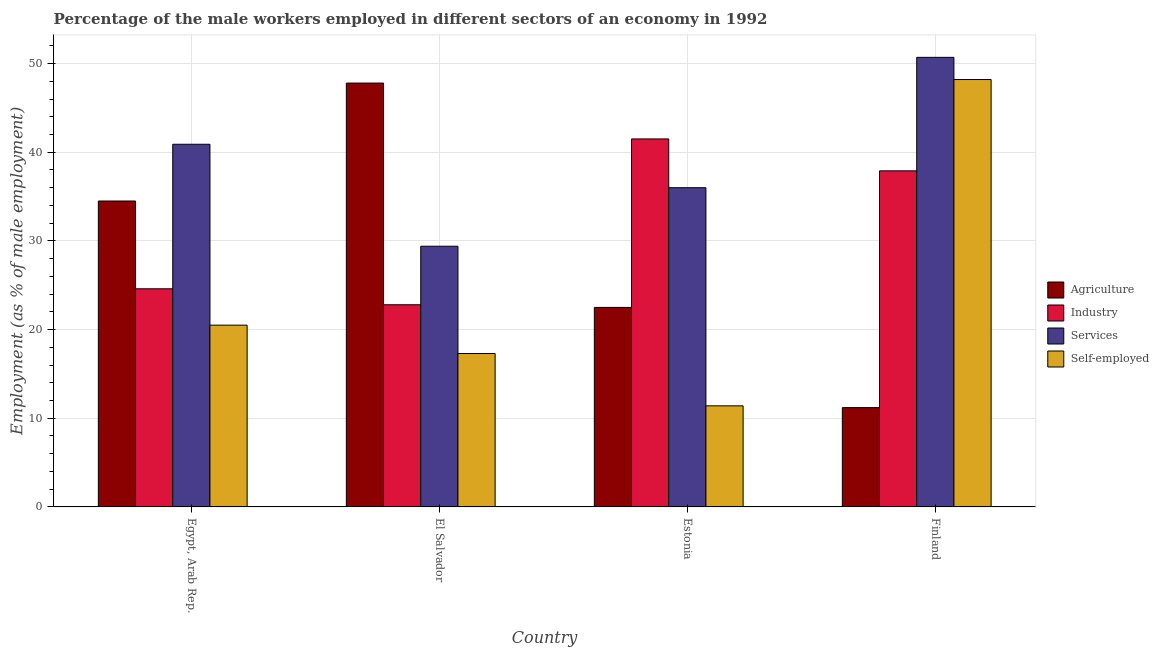How many different coloured bars are there?
Give a very brief answer. 4. How many groups of bars are there?
Your answer should be very brief. 4. How many bars are there on the 3rd tick from the left?
Give a very brief answer. 4. What is the label of the 1st group of bars from the left?
Your answer should be compact. Egypt, Arab Rep. In how many cases, is the number of bars for a given country not equal to the number of legend labels?
Make the answer very short. 0. What is the percentage of male workers in agriculture in Finland?
Offer a very short reply. 11.2. Across all countries, what is the maximum percentage of male workers in industry?
Ensure brevity in your answer.  41.5. Across all countries, what is the minimum percentage of male workers in services?
Your answer should be compact. 29.4. In which country was the percentage of male workers in agriculture maximum?
Your answer should be compact. El Salvador. In which country was the percentage of male workers in industry minimum?
Give a very brief answer. El Salvador. What is the total percentage of male workers in services in the graph?
Offer a terse response. 157. What is the difference between the percentage of male workers in industry in El Salvador and that in Estonia?
Offer a very short reply. -18.7. What is the difference between the percentage of male workers in agriculture in El Salvador and the percentage of self employed male workers in Egypt, Arab Rep.?
Give a very brief answer. 27.3. What is the average percentage of self employed male workers per country?
Keep it short and to the point. 24.35. What is the difference between the percentage of male workers in services and percentage of male workers in industry in Finland?
Offer a very short reply. 12.8. In how many countries, is the percentage of self employed male workers greater than 22 %?
Your answer should be very brief. 1. What is the ratio of the percentage of male workers in agriculture in Estonia to that in Finland?
Make the answer very short. 2.01. What is the difference between the highest and the second highest percentage of male workers in services?
Your response must be concise. 9.8. What is the difference between the highest and the lowest percentage of male workers in industry?
Your answer should be compact. 18.7. In how many countries, is the percentage of male workers in industry greater than the average percentage of male workers in industry taken over all countries?
Your response must be concise. 2. Is it the case that in every country, the sum of the percentage of male workers in industry and percentage of male workers in agriculture is greater than the sum of percentage of self employed male workers and percentage of male workers in services?
Offer a terse response. No. What does the 4th bar from the left in El Salvador represents?
Make the answer very short. Self-employed. What does the 1st bar from the right in Estonia represents?
Offer a terse response. Self-employed. Is it the case that in every country, the sum of the percentage of male workers in agriculture and percentage of male workers in industry is greater than the percentage of male workers in services?
Give a very brief answer. No. How many countries are there in the graph?
Your answer should be very brief. 4. What is the difference between two consecutive major ticks on the Y-axis?
Provide a succinct answer. 10. Are the values on the major ticks of Y-axis written in scientific E-notation?
Give a very brief answer. No. How are the legend labels stacked?
Your answer should be compact. Vertical. What is the title of the graph?
Provide a succinct answer. Percentage of the male workers employed in different sectors of an economy in 1992. What is the label or title of the Y-axis?
Offer a terse response. Employment (as % of male employment). What is the Employment (as % of male employment) of Agriculture in Egypt, Arab Rep.?
Provide a short and direct response. 34.5. What is the Employment (as % of male employment) of Industry in Egypt, Arab Rep.?
Your answer should be compact. 24.6. What is the Employment (as % of male employment) in Services in Egypt, Arab Rep.?
Offer a terse response. 40.9. What is the Employment (as % of male employment) of Self-employed in Egypt, Arab Rep.?
Your response must be concise. 20.5. What is the Employment (as % of male employment) of Agriculture in El Salvador?
Keep it short and to the point. 47.8. What is the Employment (as % of male employment) in Industry in El Salvador?
Provide a succinct answer. 22.8. What is the Employment (as % of male employment) in Services in El Salvador?
Keep it short and to the point. 29.4. What is the Employment (as % of male employment) of Self-employed in El Salvador?
Provide a short and direct response. 17.3. What is the Employment (as % of male employment) of Agriculture in Estonia?
Your answer should be very brief. 22.5. What is the Employment (as % of male employment) of Industry in Estonia?
Your response must be concise. 41.5. What is the Employment (as % of male employment) of Self-employed in Estonia?
Your answer should be very brief. 11.4. What is the Employment (as % of male employment) of Agriculture in Finland?
Give a very brief answer. 11.2. What is the Employment (as % of male employment) of Industry in Finland?
Your answer should be very brief. 37.9. What is the Employment (as % of male employment) of Services in Finland?
Your answer should be compact. 50.7. What is the Employment (as % of male employment) in Self-employed in Finland?
Provide a short and direct response. 48.2. Across all countries, what is the maximum Employment (as % of male employment) of Agriculture?
Give a very brief answer. 47.8. Across all countries, what is the maximum Employment (as % of male employment) of Industry?
Provide a short and direct response. 41.5. Across all countries, what is the maximum Employment (as % of male employment) in Services?
Keep it short and to the point. 50.7. Across all countries, what is the maximum Employment (as % of male employment) of Self-employed?
Offer a very short reply. 48.2. Across all countries, what is the minimum Employment (as % of male employment) of Agriculture?
Provide a short and direct response. 11.2. Across all countries, what is the minimum Employment (as % of male employment) in Industry?
Your answer should be compact. 22.8. Across all countries, what is the minimum Employment (as % of male employment) in Services?
Make the answer very short. 29.4. Across all countries, what is the minimum Employment (as % of male employment) of Self-employed?
Offer a terse response. 11.4. What is the total Employment (as % of male employment) in Agriculture in the graph?
Offer a terse response. 116. What is the total Employment (as % of male employment) in Industry in the graph?
Your answer should be very brief. 126.8. What is the total Employment (as % of male employment) of Services in the graph?
Your answer should be very brief. 157. What is the total Employment (as % of male employment) of Self-employed in the graph?
Provide a short and direct response. 97.4. What is the difference between the Employment (as % of male employment) in Industry in Egypt, Arab Rep. and that in El Salvador?
Your response must be concise. 1.8. What is the difference between the Employment (as % of male employment) in Services in Egypt, Arab Rep. and that in El Salvador?
Make the answer very short. 11.5. What is the difference between the Employment (as % of male employment) of Self-employed in Egypt, Arab Rep. and that in El Salvador?
Give a very brief answer. 3.2. What is the difference between the Employment (as % of male employment) of Agriculture in Egypt, Arab Rep. and that in Estonia?
Your answer should be compact. 12. What is the difference between the Employment (as % of male employment) of Industry in Egypt, Arab Rep. and that in Estonia?
Provide a succinct answer. -16.9. What is the difference between the Employment (as % of male employment) of Agriculture in Egypt, Arab Rep. and that in Finland?
Offer a terse response. 23.3. What is the difference between the Employment (as % of male employment) in Industry in Egypt, Arab Rep. and that in Finland?
Ensure brevity in your answer.  -13.3. What is the difference between the Employment (as % of male employment) of Services in Egypt, Arab Rep. and that in Finland?
Ensure brevity in your answer.  -9.8. What is the difference between the Employment (as % of male employment) of Self-employed in Egypt, Arab Rep. and that in Finland?
Provide a succinct answer. -27.7. What is the difference between the Employment (as % of male employment) of Agriculture in El Salvador and that in Estonia?
Give a very brief answer. 25.3. What is the difference between the Employment (as % of male employment) of Industry in El Salvador and that in Estonia?
Give a very brief answer. -18.7. What is the difference between the Employment (as % of male employment) of Services in El Salvador and that in Estonia?
Provide a short and direct response. -6.6. What is the difference between the Employment (as % of male employment) in Agriculture in El Salvador and that in Finland?
Keep it short and to the point. 36.6. What is the difference between the Employment (as % of male employment) of Industry in El Salvador and that in Finland?
Keep it short and to the point. -15.1. What is the difference between the Employment (as % of male employment) of Services in El Salvador and that in Finland?
Make the answer very short. -21.3. What is the difference between the Employment (as % of male employment) of Self-employed in El Salvador and that in Finland?
Provide a succinct answer. -30.9. What is the difference between the Employment (as % of male employment) of Services in Estonia and that in Finland?
Provide a succinct answer. -14.7. What is the difference between the Employment (as % of male employment) in Self-employed in Estonia and that in Finland?
Offer a terse response. -36.8. What is the difference between the Employment (as % of male employment) in Agriculture in Egypt, Arab Rep. and the Employment (as % of male employment) in Self-employed in El Salvador?
Your response must be concise. 17.2. What is the difference between the Employment (as % of male employment) in Industry in Egypt, Arab Rep. and the Employment (as % of male employment) in Services in El Salvador?
Ensure brevity in your answer.  -4.8. What is the difference between the Employment (as % of male employment) of Services in Egypt, Arab Rep. and the Employment (as % of male employment) of Self-employed in El Salvador?
Make the answer very short. 23.6. What is the difference between the Employment (as % of male employment) in Agriculture in Egypt, Arab Rep. and the Employment (as % of male employment) in Industry in Estonia?
Make the answer very short. -7. What is the difference between the Employment (as % of male employment) in Agriculture in Egypt, Arab Rep. and the Employment (as % of male employment) in Self-employed in Estonia?
Make the answer very short. 23.1. What is the difference between the Employment (as % of male employment) of Industry in Egypt, Arab Rep. and the Employment (as % of male employment) of Services in Estonia?
Keep it short and to the point. -11.4. What is the difference between the Employment (as % of male employment) of Services in Egypt, Arab Rep. and the Employment (as % of male employment) of Self-employed in Estonia?
Your answer should be very brief. 29.5. What is the difference between the Employment (as % of male employment) of Agriculture in Egypt, Arab Rep. and the Employment (as % of male employment) of Services in Finland?
Offer a very short reply. -16.2. What is the difference between the Employment (as % of male employment) in Agriculture in Egypt, Arab Rep. and the Employment (as % of male employment) in Self-employed in Finland?
Provide a succinct answer. -13.7. What is the difference between the Employment (as % of male employment) of Industry in Egypt, Arab Rep. and the Employment (as % of male employment) of Services in Finland?
Provide a short and direct response. -26.1. What is the difference between the Employment (as % of male employment) of Industry in Egypt, Arab Rep. and the Employment (as % of male employment) of Self-employed in Finland?
Give a very brief answer. -23.6. What is the difference between the Employment (as % of male employment) in Agriculture in El Salvador and the Employment (as % of male employment) in Industry in Estonia?
Provide a succinct answer. 6.3. What is the difference between the Employment (as % of male employment) of Agriculture in El Salvador and the Employment (as % of male employment) of Services in Estonia?
Your response must be concise. 11.8. What is the difference between the Employment (as % of male employment) of Agriculture in El Salvador and the Employment (as % of male employment) of Self-employed in Estonia?
Ensure brevity in your answer.  36.4. What is the difference between the Employment (as % of male employment) in Industry in El Salvador and the Employment (as % of male employment) in Services in Estonia?
Ensure brevity in your answer.  -13.2. What is the difference between the Employment (as % of male employment) of Industry in El Salvador and the Employment (as % of male employment) of Services in Finland?
Ensure brevity in your answer.  -27.9. What is the difference between the Employment (as % of male employment) in Industry in El Salvador and the Employment (as % of male employment) in Self-employed in Finland?
Provide a succinct answer. -25.4. What is the difference between the Employment (as % of male employment) in Services in El Salvador and the Employment (as % of male employment) in Self-employed in Finland?
Offer a terse response. -18.8. What is the difference between the Employment (as % of male employment) in Agriculture in Estonia and the Employment (as % of male employment) in Industry in Finland?
Give a very brief answer. -15.4. What is the difference between the Employment (as % of male employment) in Agriculture in Estonia and the Employment (as % of male employment) in Services in Finland?
Ensure brevity in your answer.  -28.2. What is the difference between the Employment (as % of male employment) of Agriculture in Estonia and the Employment (as % of male employment) of Self-employed in Finland?
Provide a succinct answer. -25.7. What is the difference between the Employment (as % of male employment) of Industry in Estonia and the Employment (as % of male employment) of Services in Finland?
Provide a short and direct response. -9.2. What is the difference between the Employment (as % of male employment) of Industry in Estonia and the Employment (as % of male employment) of Self-employed in Finland?
Your answer should be very brief. -6.7. What is the average Employment (as % of male employment) of Industry per country?
Your answer should be compact. 31.7. What is the average Employment (as % of male employment) of Services per country?
Provide a succinct answer. 39.25. What is the average Employment (as % of male employment) in Self-employed per country?
Provide a succinct answer. 24.35. What is the difference between the Employment (as % of male employment) of Agriculture and Employment (as % of male employment) of Industry in Egypt, Arab Rep.?
Offer a very short reply. 9.9. What is the difference between the Employment (as % of male employment) of Agriculture and Employment (as % of male employment) of Self-employed in Egypt, Arab Rep.?
Offer a very short reply. 14. What is the difference between the Employment (as % of male employment) of Industry and Employment (as % of male employment) of Services in Egypt, Arab Rep.?
Ensure brevity in your answer.  -16.3. What is the difference between the Employment (as % of male employment) in Industry and Employment (as % of male employment) in Self-employed in Egypt, Arab Rep.?
Offer a terse response. 4.1. What is the difference between the Employment (as % of male employment) of Services and Employment (as % of male employment) of Self-employed in Egypt, Arab Rep.?
Provide a short and direct response. 20.4. What is the difference between the Employment (as % of male employment) in Agriculture and Employment (as % of male employment) in Industry in El Salvador?
Offer a terse response. 25. What is the difference between the Employment (as % of male employment) in Agriculture and Employment (as % of male employment) in Self-employed in El Salvador?
Give a very brief answer. 30.5. What is the difference between the Employment (as % of male employment) in Industry and Employment (as % of male employment) in Self-employed in El Salvador?
Provide a short and direct response. 5.5. What is the difference between the Employment (as % of male employment) in Services and Employment (as % of male employment) in Self-employed in El Salvador?
Give a very brief answer. 12.1. What is the difference between the Employment (as % of male employment) in Agriculture and Employment (as % of male employment) in Industry in Estonia?
Give a very brief answer. -19. What is the difference between the Employment (as % of male employment) of Agriculture and Employment (as % of male employment) of Services in Estonia?
Your answer should be very brief. -13.5. What is the difference between the Employment (as % of male employment) of Industry and Employment (as % of male employment) of Self-employed in Estonia?
Your answer should be very brief. 30.1. What is the difference between the Employment (as % of male employment) in Services and Employment (as % of male employment) in Self-employed in Estonia?
Give a very brief answer. 24.6. What is the difference between the Employment (as % of male employment) in Agriculture and Employment (as % of male employment) in Industry in Finland?
Your answer should be very brief. -26.7. What is the difference between the Employment (as % of male employment) of Agriculture and Employment (as % of male employment) of Services in Finland?
Provide a short and direct response. -39.5. What is the difference between the Employment (as % of male employment) of Agriculture and Employment (as % of male employment) of Self-employed in Finland?
Offer a terse response. -37. What is the difference between the Employment (as % of male employment) of Industry and Employment (as % of male employment) of Self-employed in Finland?
Keep it short and to the point. -10.3. What is the difference between the Employment (as % of male employment) of Services and Employment (as % of male employment) of Self-employed in Finland?
Your response must be concise. 2.5. What is the ratio of the Employment (as % of male employment) in Agriculture in Egypt, Arab Rep. to that in El Salvador?
Provide a succinct answer. 0.72. What is the ratio of the Employment (as % of male employment) of Industry in Egypt, Arab Rep. to that in El Salvador?
Give a very brief answer. 1.08. What is the ratio of the Employment (as % of male employment) in Services in Egypt, Arab Rep. to that in El Salvador?
Provide a succinct answer. 1.39. What is the ratio of the Employment (as % of male employment) in Self-employed in Egypt, Arab Rep. to that in El Salvador?
Offer a terse response. 1.19. What is the ratio of the Employment (as % of male employment) in Agriculture in Egypt, Arab Rep. to that in Estonia?
Your answer should be very brief. 1.53. What is the ratio of the Employment (as % of male employment) of Industry in Egypt, Arab Rep. to that in Estonia?
Ensure brevity in your answer.  0.59. What is the ratio of the Employment (as % of male employment) in Services in Egypt, Arab Rep. to that in Estonia?
Your response must be concise. 1.14. What is the ratio of the Employment (as % of male employment) of Self-employed in Egypt, Arab Rep. to that in Estonia?
Provide a short and direct response. 1.8. What is the ratio of the Employment (as % of male employment) of Agriculture in Egypt, Arab Rep. to that in Finland?
Offer a very short reply. 3.08. What is the ratio of the Employment (as % of male employment) of Industry in Egypt, Arab Rep. to that in Finland?
Provide a short and direct response. 0.65. What is the ratio of the Employment (as % of male employment) in Services in Egypt, Arab Rep. to that in Finland?
Offer a very short reply. 0.81. What is the ratio of the Employment (as % of male employment) of Self-employed in Egypt, Arab Rep. to that in Finland?
Keep it short and to the point. 0.43. What is the ratio of the Employment (as % of male employment) in Agriculture in El Salvador to that in Estonia?
Your answer should be very brief. 2.12. What is the ratio of the Employment (as % of male employment) in Industry in El Salvador to that in Estonia?
Provide a short and direct response. 0.55. What is the ratio of the Employment (as % of male employment) in Services in El Salvador to that in Estonia?
Make the answer very short. 0.82. What is the ratio of the Employment (as % of male employment) of Self-employed in El Salvador to that in Estonia?
Give a very brief answer. 1.52. What is the ratio of the Employment (as % of male employment) in Agriculture in El Salvador to that in Finland?
Offer a terse response. 4.27. What is the ratio of the Employment (as % of male employment) of Industry in El Salvador to that in Finland?
Keep it short and to the point. 0.6. What is the ratio of the Employment (as % of male employment) of Services in El Salvador to that in Finland?
Make the answer very short. 0.58. What is the ratio of the Employment (as % of male employment) in Self-employed in El Salvador to that in Finland?
Give a very brief answer. 0.36. What is the ratio of the Employment (as % of male employment) of Agriculture in Estonia to that in Finland?
Your answer should be very brief. 2.01. What is the ratio of the Employment (as % of male employment) of Industry in Estonia to that in Finland?
Keep it short and to the point. 1.09. What is the ratio of the Employment (as % of male employment) in Services in Estonia to that in Finland?
Offer a very short reply. 0.71. What is the ratio of the Employment (as % of male employment) in Self-employed in Estonia to that in Finland?
Your answer should be very brief. 0.24. What is the difference between the highest and the second highest Employment (as % of male employment) of Industry?
Your response must be concise. 3.6. What is the difference between the highest and the second highest Employment (as % of male employment) in Self-employed?
Offer a terse response. 27.7. What is the difference between the highest and the lowest Employment (as % of male employment) in Agriculture?
Offer a very short reply. 36.6. What is the difference between the highest and the lowest Employment (as % of male employment) of Services?
Your answer should be compact. 21.3. What is the difference between the highest and the lowest Employment (as % of male employment) in Self-employed?
Ensure brevity in your answer.  36.8. 